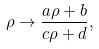Convert formula to latex. <formula><loc_0><loc_0><loc_500><loc_500>\rho \rightarrow \frac { a \rho + b } { c \rho + d } ,</formula> 